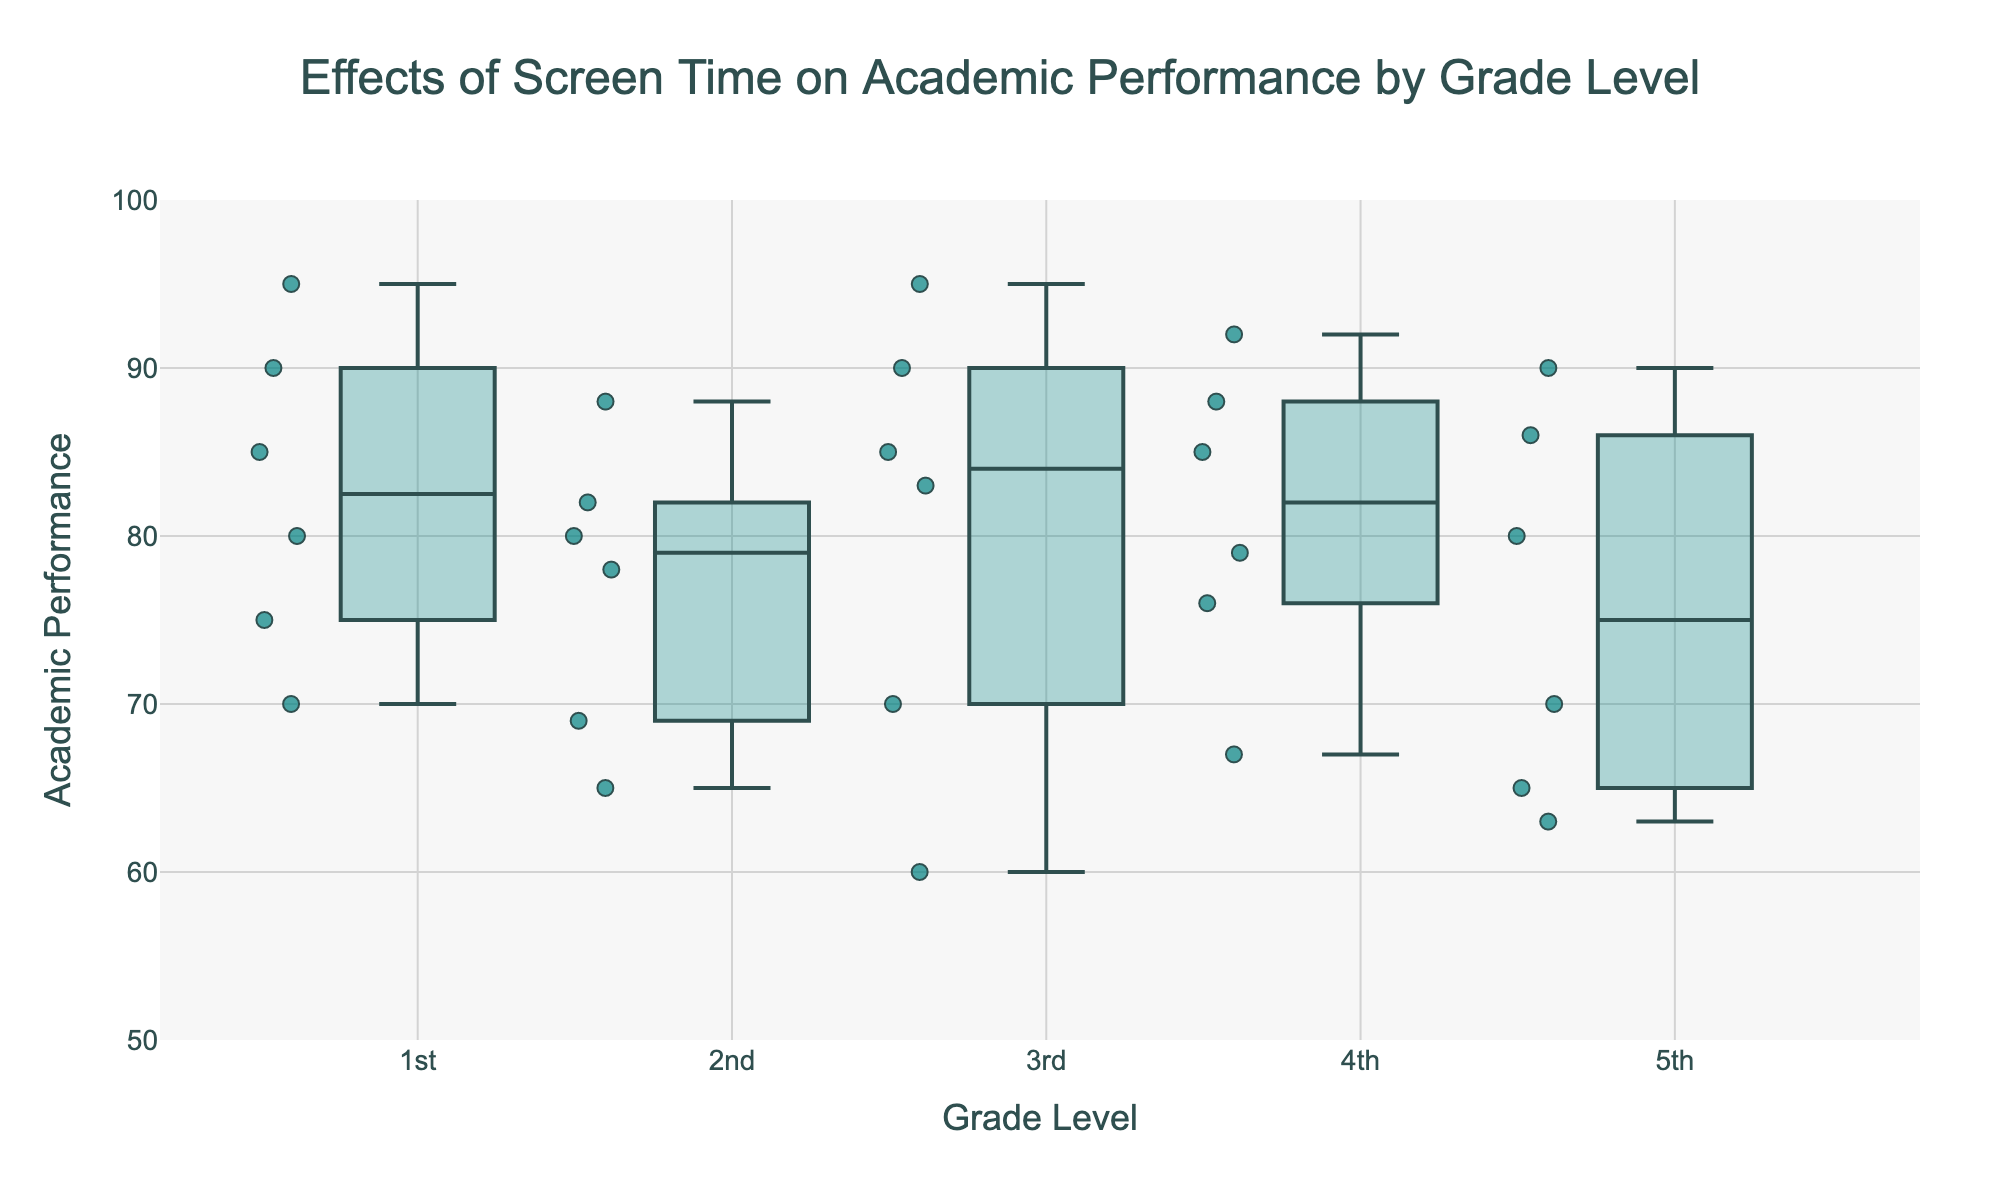How is the title of the figure phrased? The title is written at the top of the figure, centered and large. It reads: "Effects of Screen Time on Academic Performance by Grade Level".
Answer: "Effects of Screen Time on Academic Performance by Grade Level" What does the y-axis represent? The y-axis has a label next to it that reads "Academic Performance".
Answer: "Academic Performance" What grade level has the highest median academic performance? By looking at the height of the median lines (marked by a central line in each box). The 1st grade level has the highest median academic performance.
Answer: 1st grade Which grade level shows the widest range in academic performance? The widest range is determined by the vertical distance between the top (maximum) and bottom (minimum) of the boxplot. The 4th grade level has the widest range in academic performance.
Answer: 4th grade How does the median academic performance of the 5th grade compare to the 1st grade? The median is the central line inside each box. The median academic performance of the 5th grade is lower compared to the median of the 1st grade.
Answer: Lower Are there more data points above the median for 1st grade or 3rd grade? Observing the jittered points (scatter points) on each grade level's boxplot and comparing their density above the median line. 1st grade has more data points above the median.
Answer: 1st grade What is the color used for the markers? The markers for the data points are filled with a turquoise color and have a dark outline.
Answer: Turquoise How does the variability in academic performance change from 1st to 5th grade? Variability can be inferred by the height of the boxes and the scattering of the points. The variability in academic performance tends to increase as the grade level goes from 1st to 5th grade, with the range becoming wider.
Answer: Increases What is the highest academic performance recorded, and in which grade? The highest performance is identified by the topmost point in all box plots. The highest academic performance recorded is 95 in both 1st and 3rd grades.
Answer: 95 in 1st and 3rd grade 